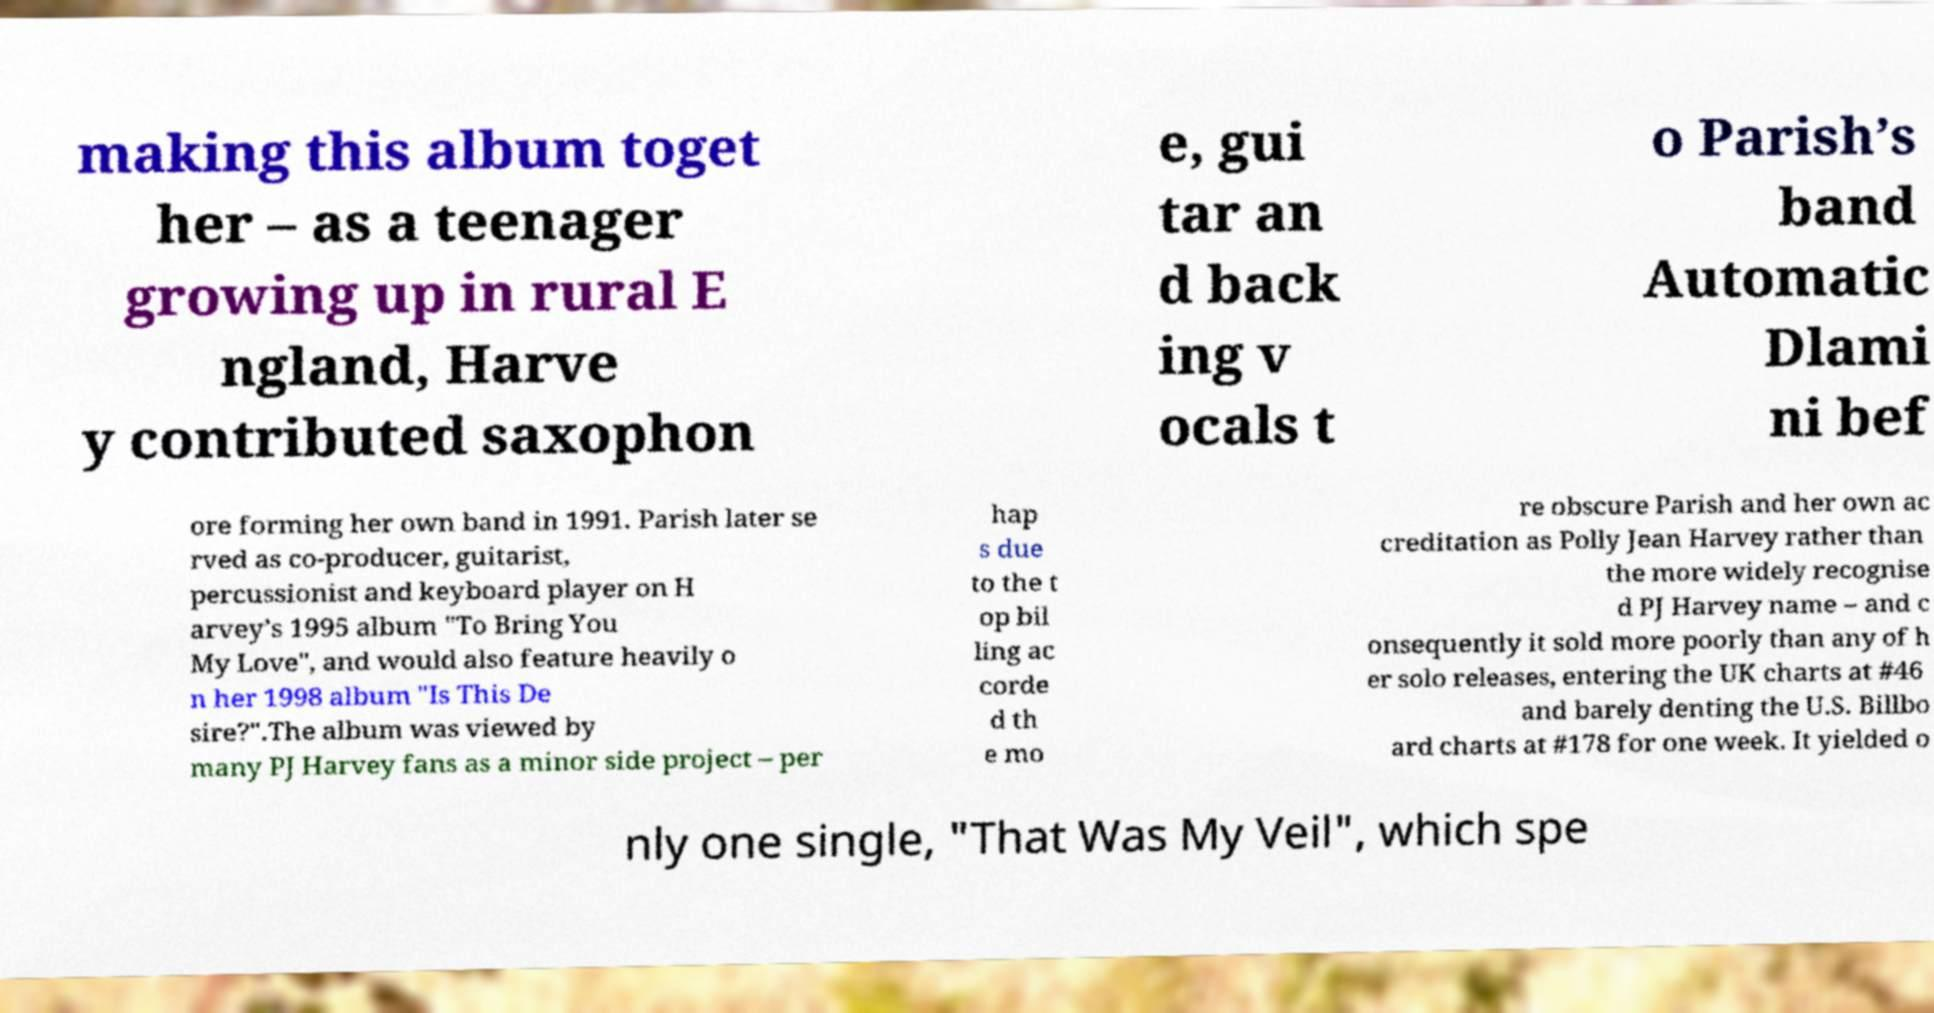Can you read and provide the text displayed in the image?This photo seems to have some interesting text. Can you extract and type it out for me? making this album toget her – as a teenager growing up in rural E ngland, Harve y contributed saxophon e, gui tar an d back ing v ocals t o Parish’s band Automatic Dlami ni bef ore forming her own band in 1991. Parish later se rved as co-producer, guitarist, percussionist and keyboard player on H arvey’s 1995 album "To Bring You My Love", and would also feature heavily o n her 1998 album "Is This De sire?".The album was viewed by many PJ Harvey fans as a minor side project – per hap s due to the t op bil ling ac corde d th e mo re obscure Parish and her own ac creditation as Polly Jean Harvey rather than the more widely recognise d PJ Harvey name – and c onsequently it sold more poorly than any of h er solo releases, entering the UK charts at #46 and barely denting the U.S. Billbo ard charts at #178 for one week. It yielded o nly one single, "That Was My Veil", which spe 